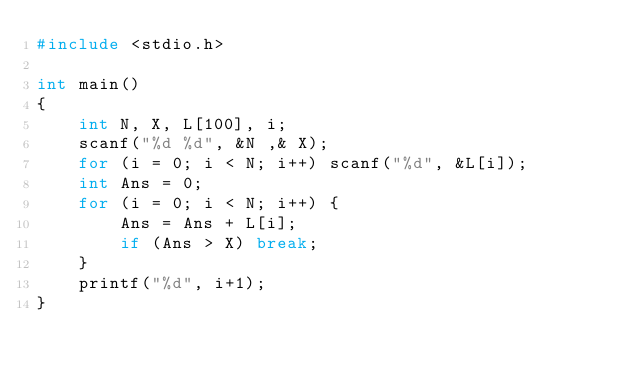<code> <loc_0><loc_0><loc_500><loc_500><_C_>#include <stdio.h>

int main()
{
	int N, X, L[100], i;
	scanf("%d %d", &N ,& X);
	for (i = 0; i < N; i++) scanf("%d", &L[i]);
	int Ans = 0;
	for (i = 0; i < N; i++) {
		Ans = Ans + L[i];
		if (Ans > X) break;
	}
	printf("%d", i+1);
}</code> 